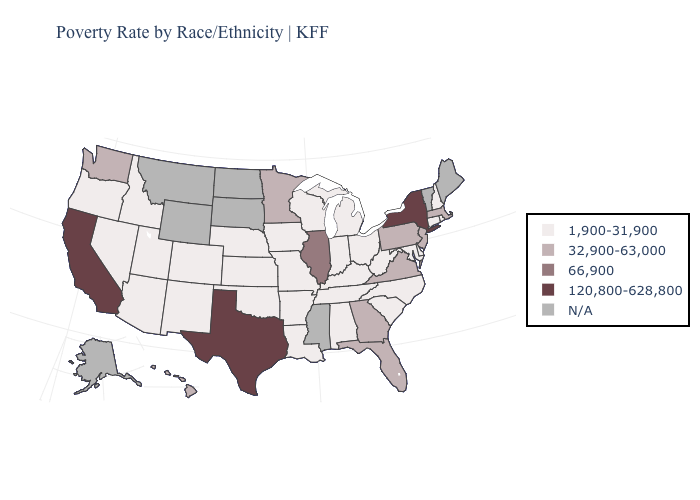Name the states that have a value in the range 1,900-31,900?
Keep it brief. Alabama, Arizona, Arkansas, Colorado, Connecticut, Delaware, Idaho, Indiana, Iowa, Kansas, Kentucky, Louisiana, Maryland, Michigan, Missouri, Nebraska, Nevada, New Hampshire, New Mexico, North Carolina, Ohio, Oklahoma, Oregon, Rhode Island, South Carolina, Tennessee, Utah, West Virginia, Wisconsin. What is the value of Nebraska?
Concise answer only. 1,900-31,900. Name the states that have a value in the range 66,900?
Write a very short answer. Illinois. Does New York have the lowest value in the USA?
Concise answer only. No. What is the value of South Carolina?
Quick response, please. 1,900-31,900. Name the states that have a value in the range 120,800-628,800?
Write a very short answer. California, New York, Texas. Among the states that border Pennsylvania , which have the lowest value?
Give a very brief answer. Delaware, Maryland, Ohio, West Virginia. Which states have the lowest value in the USA?
Short answer required. Alabama, Arizona, Arkansas, Colorado, Connecticut, Delaware, Idaho, Indiana, Iowa, Kansas, Kentucky, Louisiana, Maryland, Michigan, Missouri, Nebraska, Nevada, New Hampshire, New Mexico, North Carolina, Ohio, Oklahoma, Oregon, Rhode Island, South Carolina, Tennessee, Utah, West Virginia, Wisconsin. Which states have the lowest value in the MidWest?
Quick response, please. Indiana, Iowa, Kansas, Michigan, Missouri, Nebraska, Ohio, Wisconsin. Name the states that have a value in the range N/A?
Answer briefly. Alaska, Maine, Mississippi, Montana, North Dakota, South Dakota, Vermont, Wyoming. What is the value of Massachusetts?
Keep it brief. 32,900-63,000. What is the value of West Virginia?
Give a very brief answer. 1,900-31,900. Does Pennsylvania have the lowest value in the USA?
Write a very short answer. No. Is the legend a continuous bar?
Short answer required. No. 